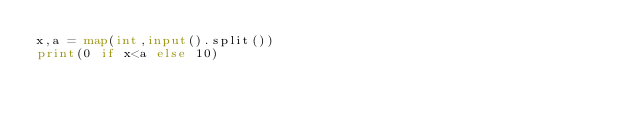Convert code to text. <code><loc_0><loc_0><loc_500><loc_500><_Python_>x,a = map(int,input().split())
print(0 if x<a else 10)
</code> 